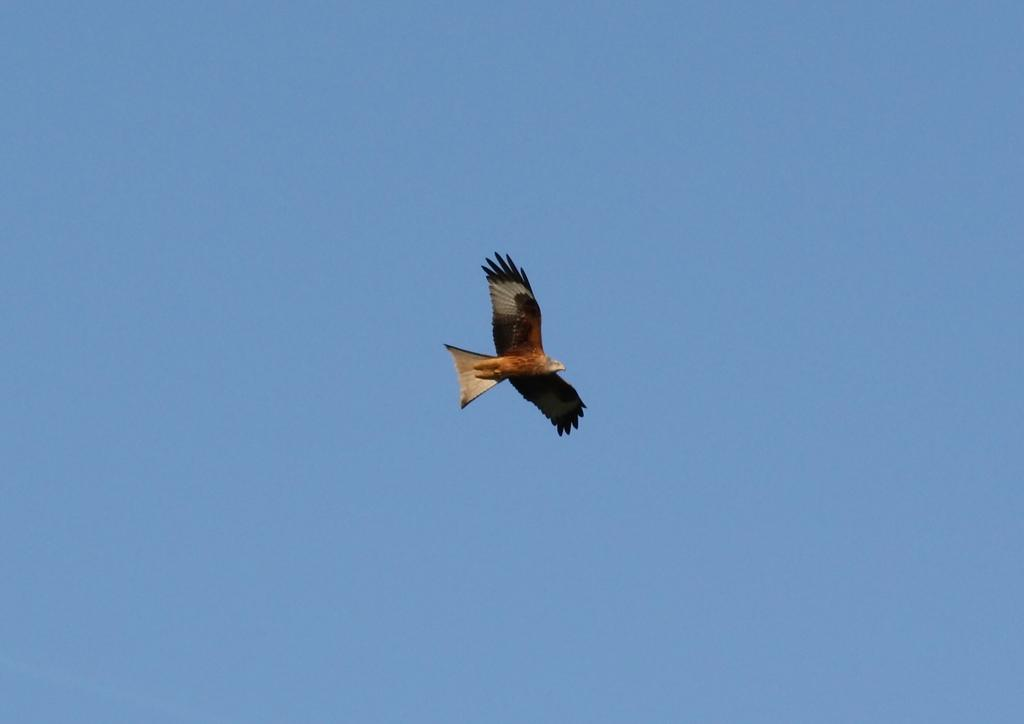What animal is present in the image? There is an eagle in the image. What is the eagle doing in the image? The eagle is flying in the sky. What type of police vehicle can be seen in the image? There is no police vehicle present in the image; it only features an eagle flying in the sky. 